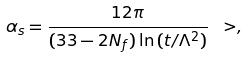Convert formula to latex. <formula><loc_0><loc_0><loc_500><loc_500>\alpha _ { s } = \frac { 1 2 \pi } { ( 3 3 - 2 N _ { f } ) \ln { ( t / \Lambda ^ { 2 } ) } } \ > ,</formula> 